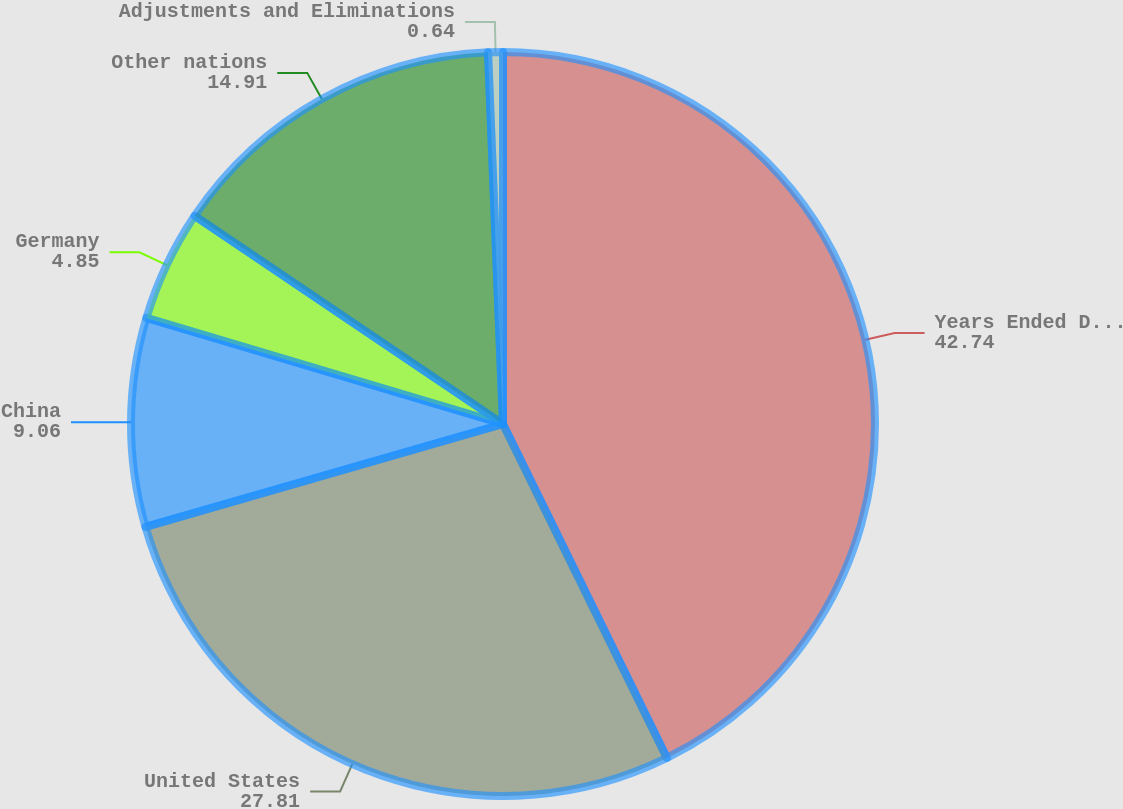<chart> <loc_0><loc_0><loc_500><loc_500><pie_chart><fcel>Years Ended December 31<fcel>United States<fcel>China<fcel>Germany<fcel>Other nations<fcel>Adjustments and Eliminations<nl><fcel>42.74%<fcel>27.81%<fcel>9.06%<fcel>4.85%<fcel>14.91%<fcel>0.64%<nl></chart> 